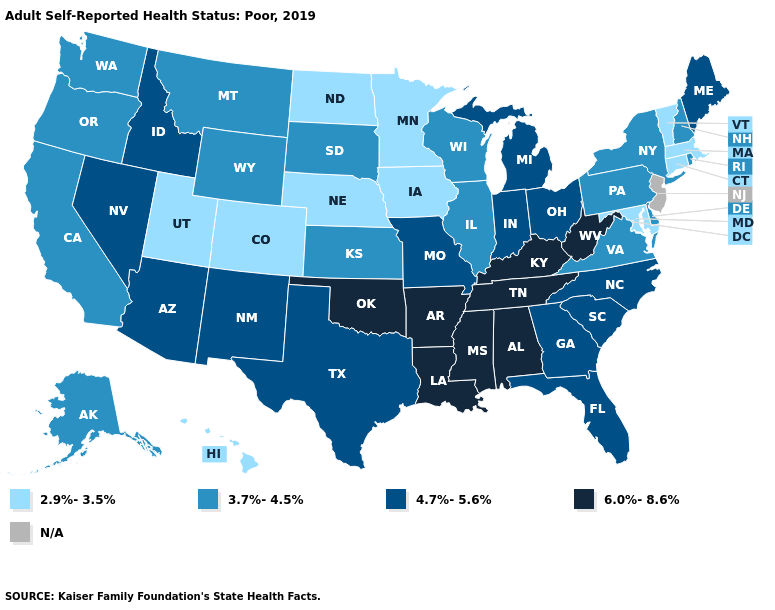Name the states that have a value in the range 2.9%-3.5%?
Concise answer only. Colorado, Connecticut, Hawaii, Iowa, Maryland, Massachusetts, Minnesota, Nebraska, North Dakota, Utah, Vermont. What is the value of Iowa?
Give a very brief answer. 2.9%-3.5%. Does Minnesota have the lowest value in the USA?
Be succinct. Yes. Name the states that have a value in the range N/A?
Give a very brief answer. New Jersey. What is the value of Rhode Island?
Write a very short answer. 3.7%-4.5%. Name the states that have a value in the range N/A?
Be succinct. New Jersey. What is the highest value in states that border West Virginia?
Concise answer only. 6.0%-8.6%. Which states have the highest value in the USA?
Quick response, please. Alabama, Arkansas, Kentucky, Louisiana, Mississippi, Oklahoma, Tennessee, West Virginia. How many symbols are there in the legend?
Answer briefly. 5. Among the states that border Washington , does Idaho have the lowest value?
Keep it brief. No. Name the states that have a value in the range 4.7%-5.6%?
Be succinct. Arizona, Florida, Georgia, Idaho, Indiana, Maine, Michigan, Missouri, Nevada, New Mexico, North Carolina, Ohio, South Carolina, Texas. Which states have the lowest value in the West?
Quick response, please. Colorado, Hawaii, Utah. Does the map have missing data?
Concise answer only. Yes. What is the value of Massachusetts?
Keep it brief. 2.9%-3.5%. 